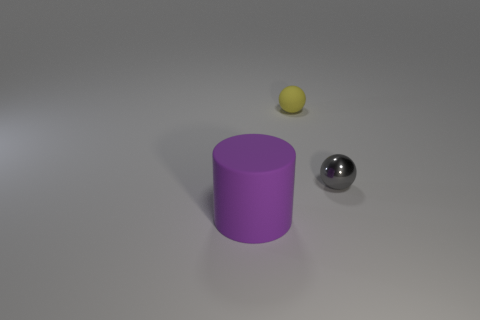Are there fewer objects left of the purple matte cylinder than large brown rubber things?
Your response must be concise. No. How many small shiny balls are the same color as the big object?
Make the answer very short. 0. Are there fewer big cyan metal cubes than gray metallic balls?
Your answer should be compact. Yes. Is the yellow object made of the same material as the large purple object?
Offer a very short reply. Yes. How many other objects are there of the same size as the matte cylinder?
Make the answer very short. 0. There is a ball to the right of the rubber object that is behind the big matte object; what is its color?
Your answer should be compact. Gray. What number of other objects are there of the same shape as the big object?
Ensure brevity in your answer.  0. Are there any large gray objects made of the same material as the small gray ball?
Give a very brief answer. No. There is a yellow ball that is the same size as the gray metal object; what is it made of?
Your answer should be compact. Rubber. There is a thing that is right of the tiny sphere to the left of the small object in front of the small yellow matte sphere; what color is it?
Give a very brief answer. Gray. 